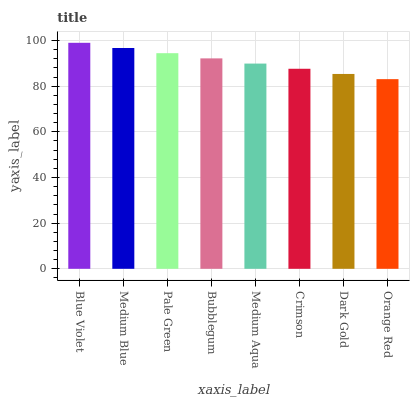Is Medium Blue the minimum?
Answer yes or no. No. Is Medium Blue the maximum?
Answer yes or no. No. Is Blue Violet greater than Medium Blue?
Answer yes or no. Yes. Is Medium Blue less than Blue Violet?
Answer yes or no. Yes. Is Medium Blue greater than Blue Violet?
Answer yes or no. No. Is Blue Violet less than Medium Blue?
Answer yes or no. No. Is Bubblegum the high median?
Answer yes or no. Yes. Is Medium Aqua the low median?
Answer yes or no. Yes. Is Pale Green the high median?
Answer yes or no. No. Is Crimson the low median?
Answer yes or no. No. 